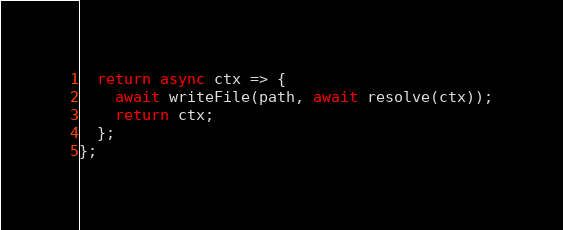<code> <loc_0><loc_0><loc_500><loc_500><_TypeScript_>  return async ctx => {
    await writeFile(path, await resolve(ctx));
    return ctx;
  };
};
</code> 